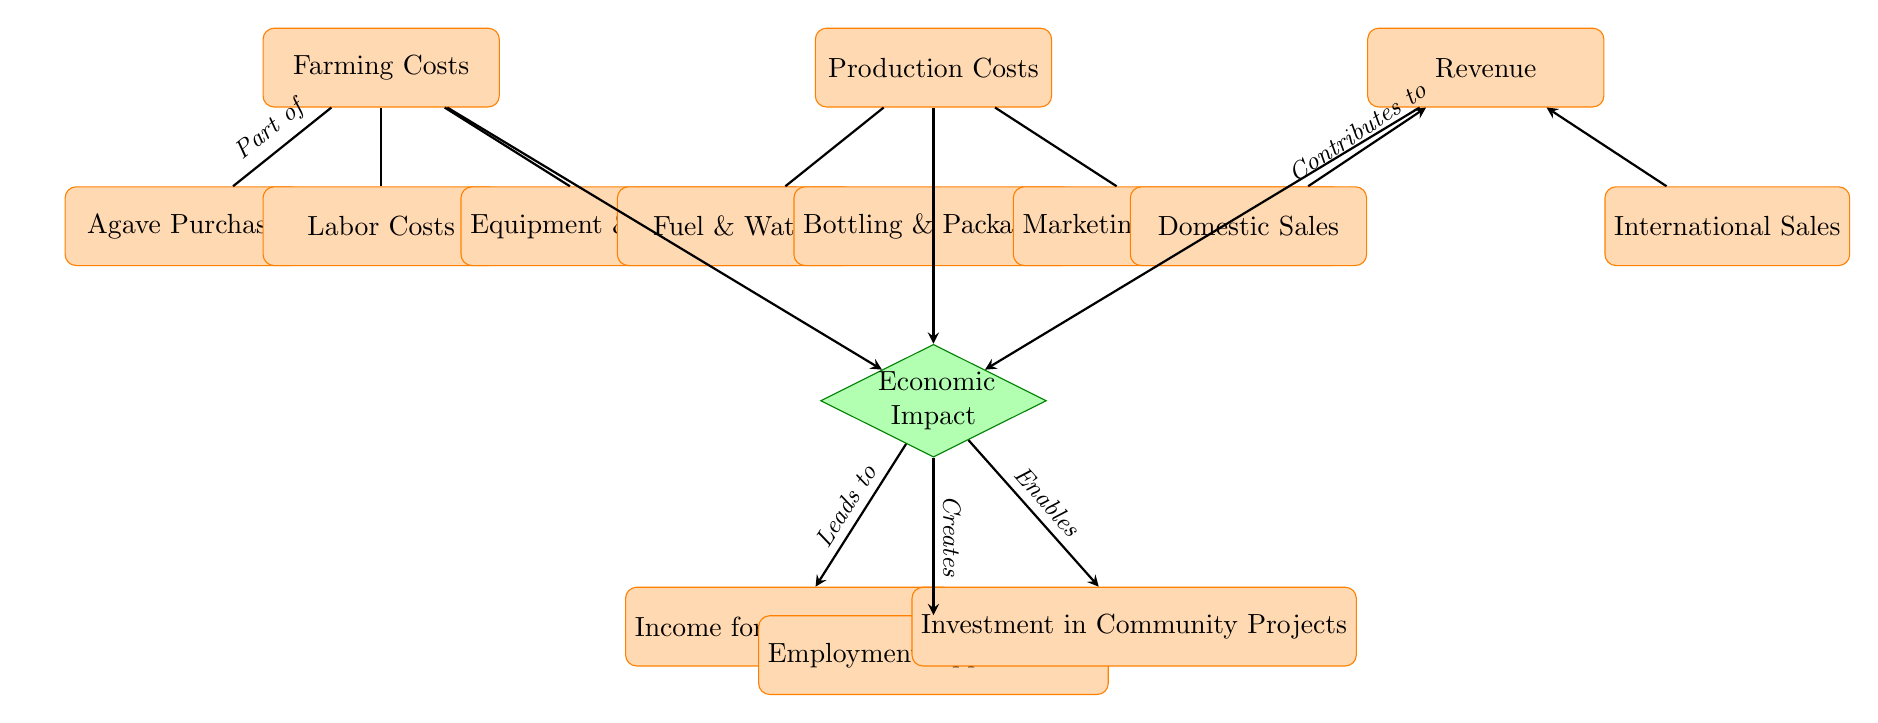What are the main components of farming costs? The farming costs consist of three components: Agave Purchase, Labor Costs, and Equipment & Maintenance. These nodes are directly connected to the central Farming Costs node in the diagram.
Answer: Agave Purchase, Labor Costs, Equipment & Maintenance How many sub-nodes are there under production costs? Under the Production Costs node, there are three sub-nodes: Fuel & Water, Bottling & Packaging, and Marketing & Distribution. Counting these gives a total of three sub-nodes.
Answer: 3 What is the relationship between Domestic Sales and Revenue? The Domestic Sales node is directly connected to the Revenue node and labeled as contributing to revenue. This indicates a positive impact of domestic sales on overall revenue.
Answer: Contributes to What enables investment in community projects? Investment in Community Projects stems from the Economic Impact node, which aggregates effects from Farming Costs, Production Costs, and Revenue. Thus, the connections show that the economic impact enables investment.
Answer: Economic Impact Which node represents income for local farmers? The node labeled "Income for Local Farmers" is directly below the Economic Impact node, indicating that it is one of the outcomes of the overall economic impact derived from mezcal production.
Answer: Income for Local Farmers 